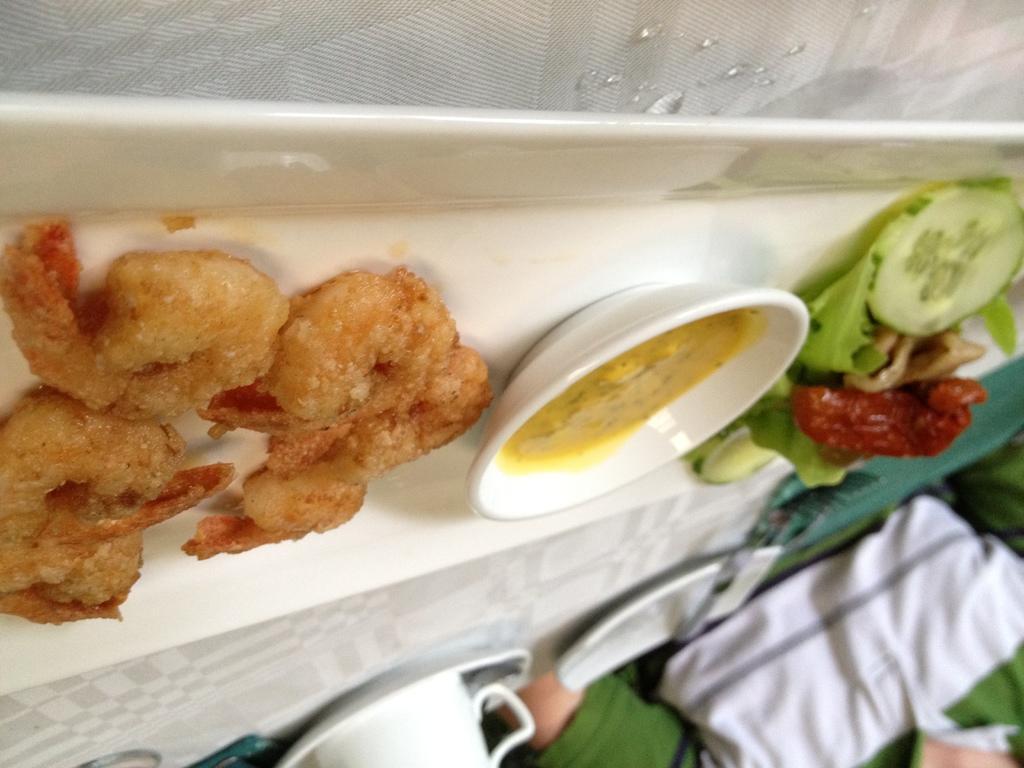How would you summarize this image in a sentence or two? In the picture we can see a white color tray on it, we can see some fried food and a bowl with soup, which is yellow in color and beside it, we can see some vegetable salads and beside the tray we can see a cup and saucer and a person sitting near the table. 